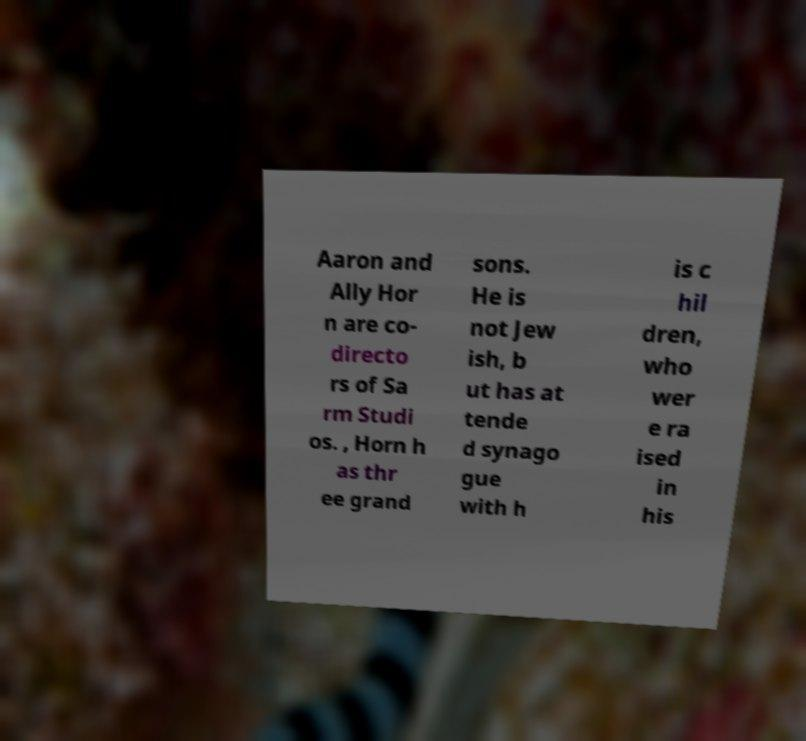There's text embedded in this image that I need extracted. Can you transcribe it verbatim? Aaron and Ally Hor n are co- directo rs of Sa rm Studi os. , Horn h as thr ee grand sons. He is not Jew ish, b ut has at tende d synago gue with h is c hil dren, who wer e ra ised in his 